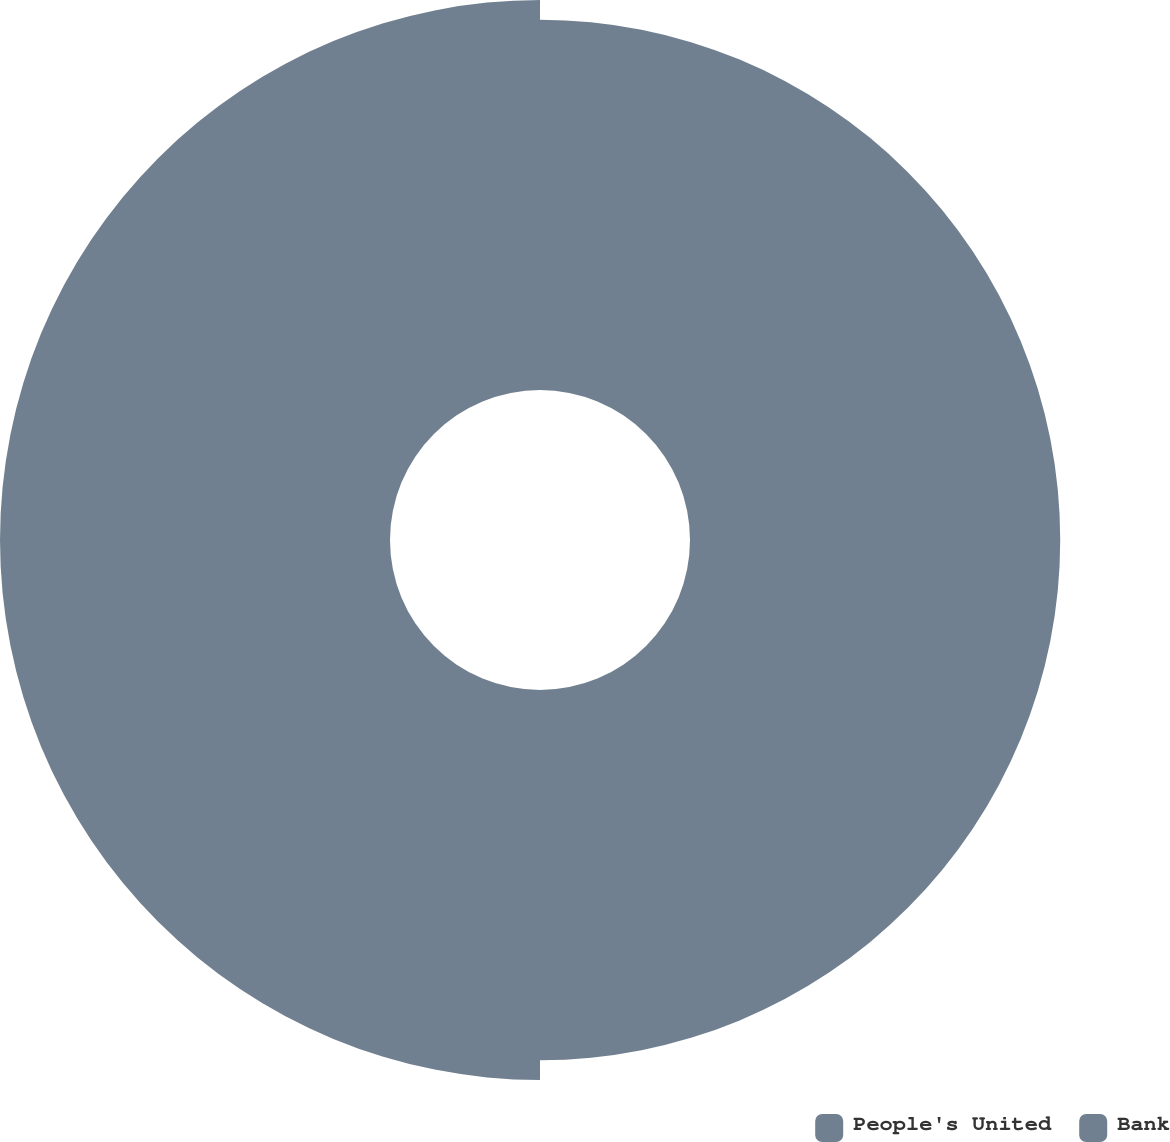Convert chart. <chart><loc_0><loc_0><loc_500><loc_500><pie_chart><fcel>People's United<fcel>Bank<nl><fcel>48.7%<fcel>51.3%<nl></chart> 